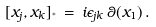<formula> <loc_0><loc_0><loc_500><loc_500>[ x _ { j } , x _ { k } ] _ { ^ { * } } \, = \, i \epsilon _ { j k } \, \theta ( x _ { 1 } ) \, .</formula> 